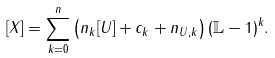<formula> <loc_0><loc_0><loc_500><loc_500>[ X ] = \sum _ { k = 0 } ^ { n } \left ( n _ { k } [ U ] + c _ { k } + n _ { U , k } \right ) ( \mathbb { L } - 1 ) ^ { k } .</formula> 